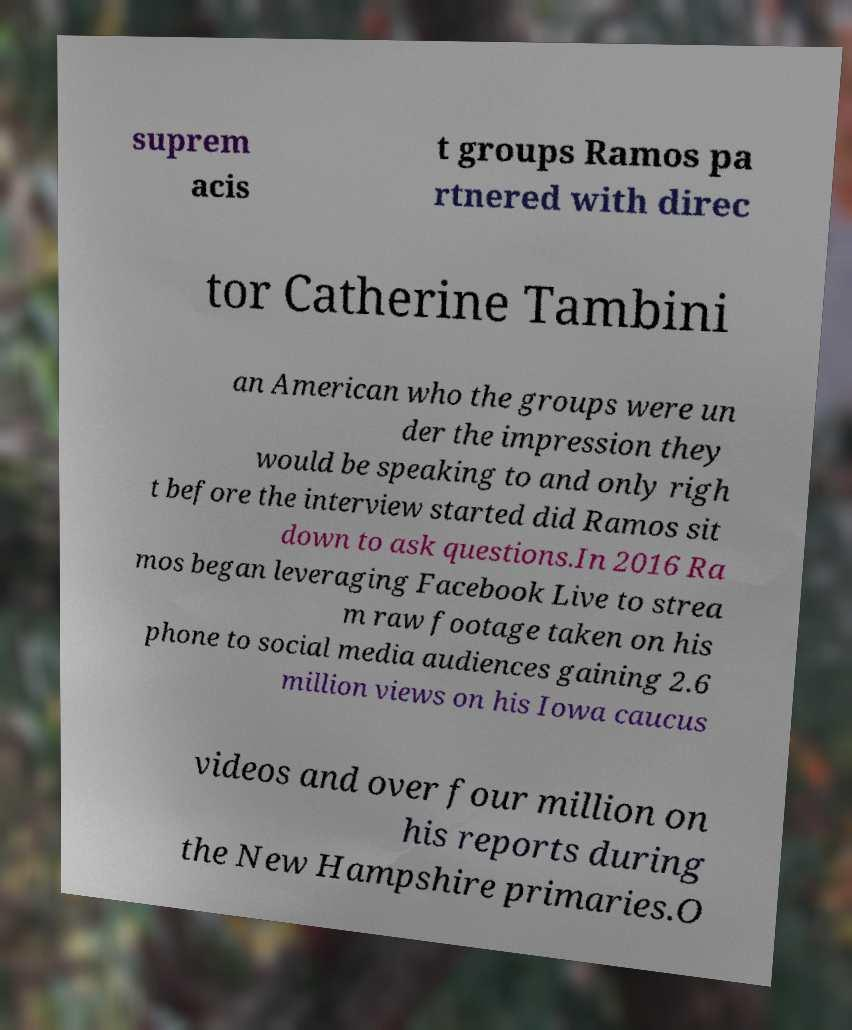There's text embedded in this image that I need extracted. Can you transcribe it verbatim? suprem acis t groups Ramos pa rtnered with direc tor Catherine Tambini an American who the groups were un der the impression they would be speaking to and only righ t before the interview started did Ramos sit down to ask questions.In 2016 Ra mos began leveraging Facebook Live to strea m raw footage taken on his phone to social media audiences gaining 2.6 million views on his Iowa caucus videos and over four million on his reports during the New Hampshire primaries.O 